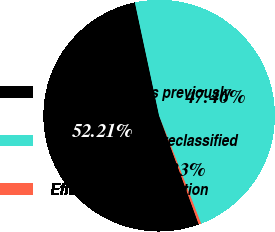<chart> <loc_0><loc_0><loc_500><loc_500><pie_chart><fcel>Gross margin as previously<fcel>Gross margin as reclassified<fcel>Effect of reclassification<nl><fcel>52.21%<fcel>47.46%<fcel>0.33%<nl></chart> 